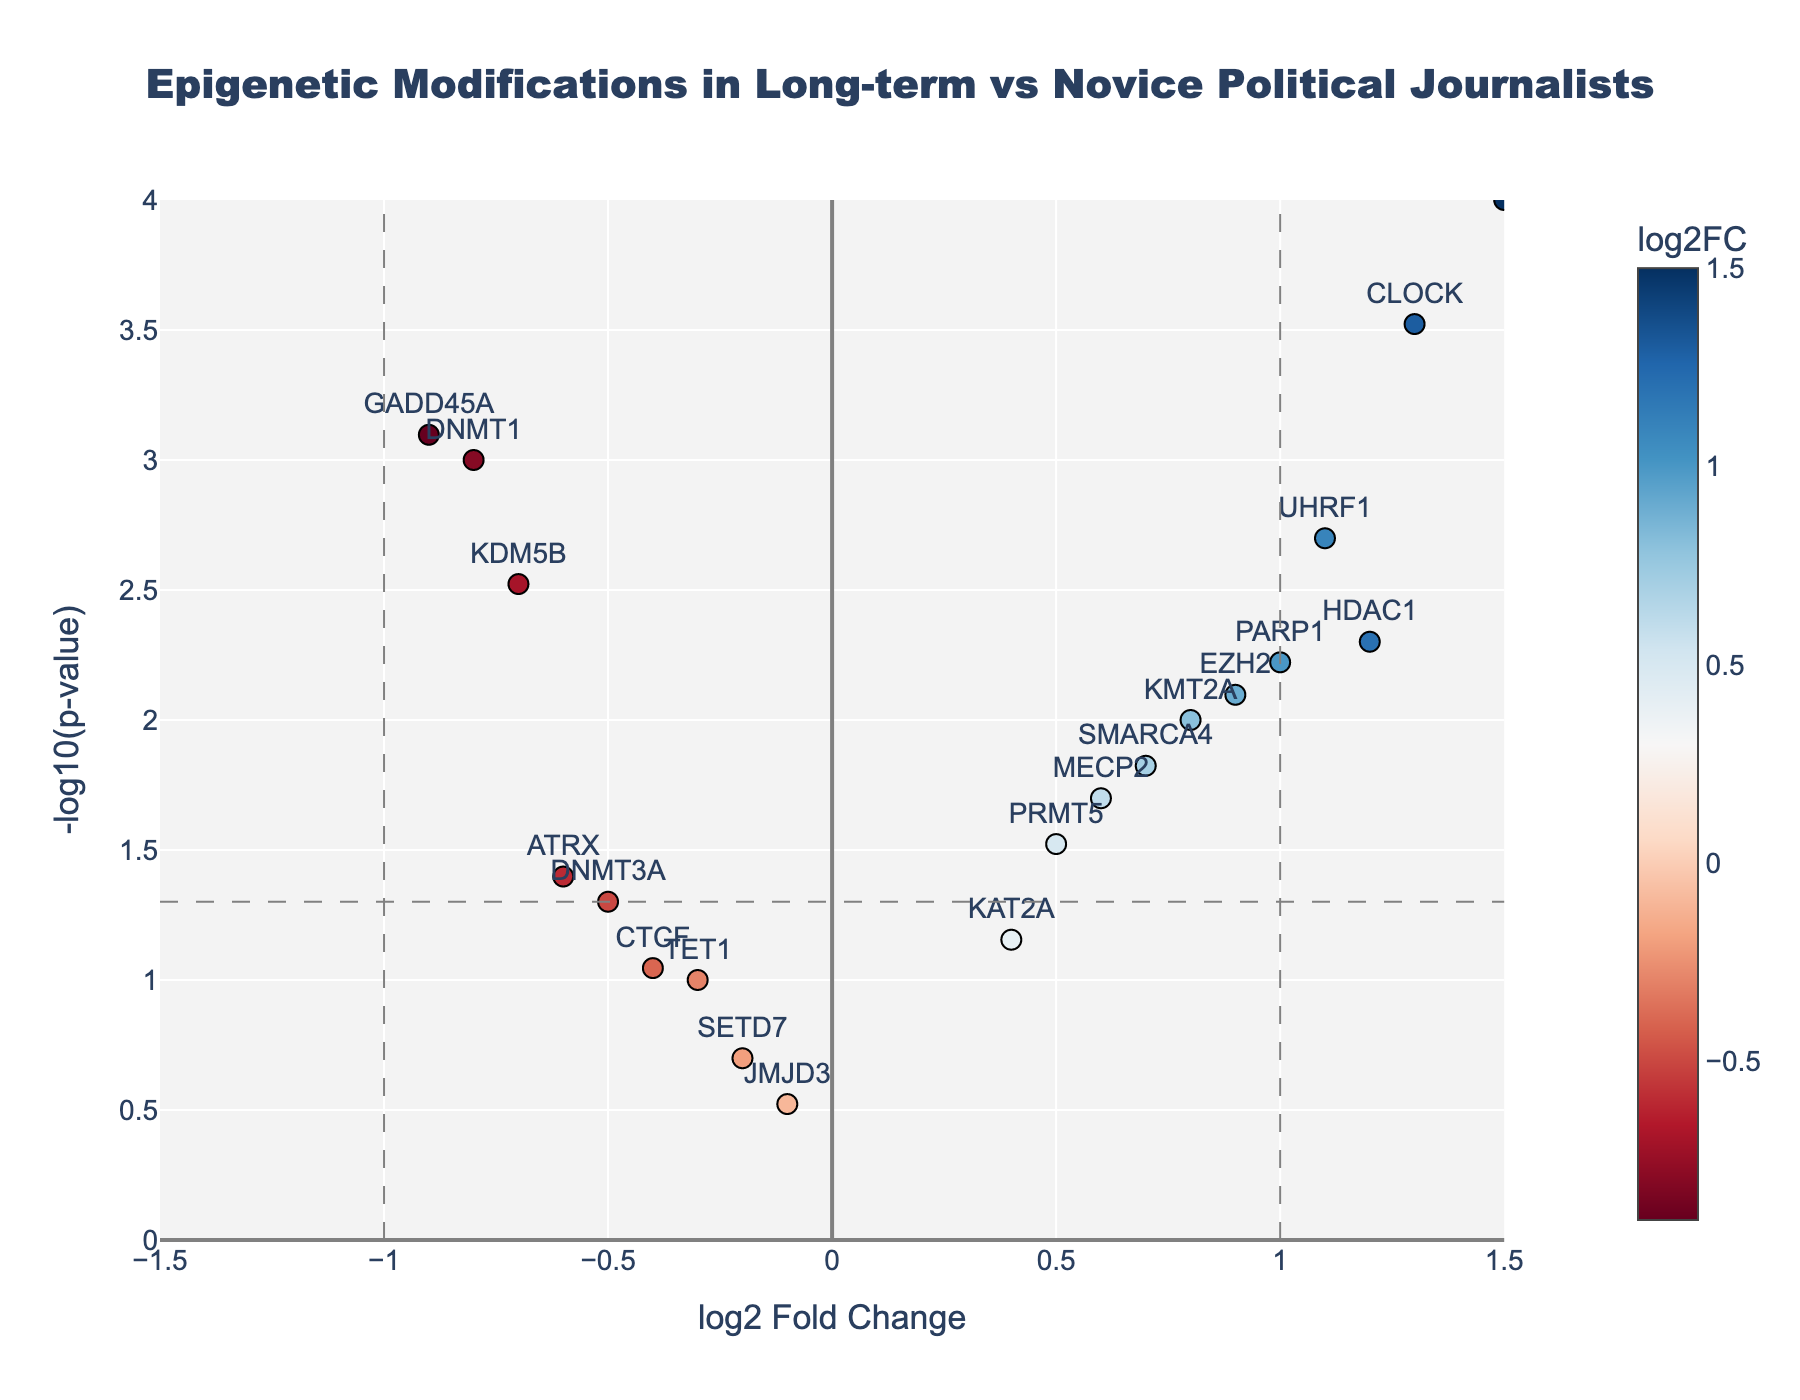What is the title of the figure? The title is usually written at the top of the figure and helps to understand the data being represented. In this case, the title is "Epigenetic Modifications in Long-term vs Novice Political Journalists," which suggests that it compares gene expression changes between these two groups.
Answer: Epigenetic Modifications in Long-term vs Novice Political Journalists What is the x-axis representing? The x-axis represents the log2 Fold Change, which shows the logarithmic ratio of gene expression levels between long-term political journalists and novice reporters.
Answer: log2 Fold Change What is the y-axis representing? The y-axis represents -log10(p-value), which indicates the significance of the gene expression changes. Higher values denote stronger statistical significance.
Answer: -log10(p-value) How many genes show a log2 Fold Change greater than 1? By examining the plot, we look for genes positioned to the right of the vertical line at log2 Fold Change = 1. A close look indicates that there are three genes in this sector.
Answer: 3 Which gene has the highest log2 Fold Change? To determine this, we look for the highest data point along the x-axis. This gene is clearly marked and is colored in a different hue indicating the high fold change. The gene named SIRT1 has the highest log2 Fold Change.
Answer: SIRT1 Which gene has the lowest p-value? The lowest p-value will have the highest -log10(p-value) value. By examining the plot, the gene named SIRT1 is the most significant as it appears at the topmost point on the y-axis.
Answer: SIRT1 Are there any genes with a log2 Fold Change less than -1? To find this, we check the left side of the vertical line positioned at -1 on the x-axis. There are no genes in this area.
Answer: No Which gene has a log2 Fold Change close to zero but a significant p-value? We look for a gene near the x-axis zero line with a high -log10(p-value) value. The gene named TET1 fits this description, having a log2 Fold Change of -0.3 and a noticeable p-value.
Answer: TET1 What color scale is used to represent log2 Fold Change in the plot? The color scale used is 'RdBu' where red likely indicates downregulation (negative log2 Fold Change) and blue indicates upregulation (positive log2 Fold Change).
Answer: RdBu What is the significance threshold for the p-value indicated in the plot? The significance threshold is shown by the horizontal dashed line, which represents a p-value of 0.05. This corresponds to a -log10(p-value) of 1.3 on the y-axis.
Answer: 0.05 